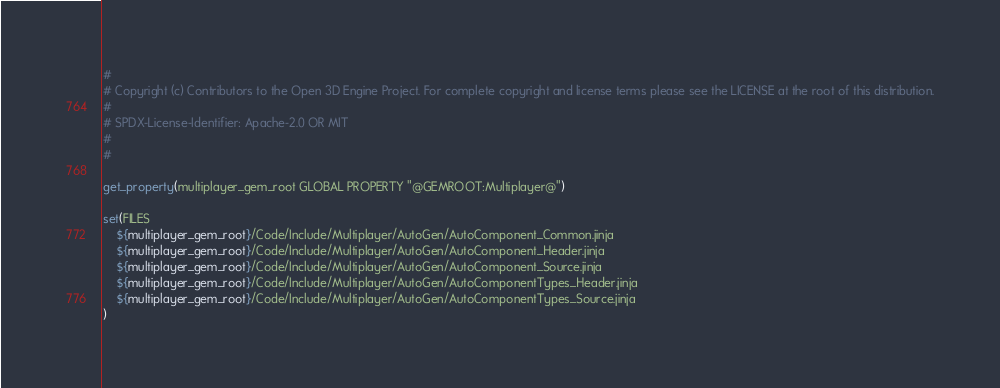<code> <loc_0><loc_0><loc_500><loc_500><_CMake_>#
# Copyright (c) Contributors to the Open 3D Engine Project. For complete copyright and license terms please see the LICENSE at the root of this distribution.
# 
# SPDX-License-Identifier: Apache-2.0 OR MIT
#
#

get_property(multiplayer_gem_root GLOBAL PROPERTY "@GEMROOT:Multiplayer@")

set(FILES
    ${multiplayer_gem_root}/Code/Include/Multiplayer/AutoGen/AutoComponent_Common.jinja
    ${multiplayer_gem_root}/Code/Include/Multiplayer/AutoGen/AutoComponent_Header.jinja
    ${multiplayer_gem_root}/Code/Include/Multiplayer/AutoGen/AutoComponent_Source.jinja
    ${multiplayer_gem_root}/Code/Include/Multiplayer/AutoGen/AutoComponentTypes_Header.jinja
    ${multiplayer_gem_root}/Code/Include/Multiplayer/AutoGen/AutoComponentTypes_Source.jinja
)
</code> 